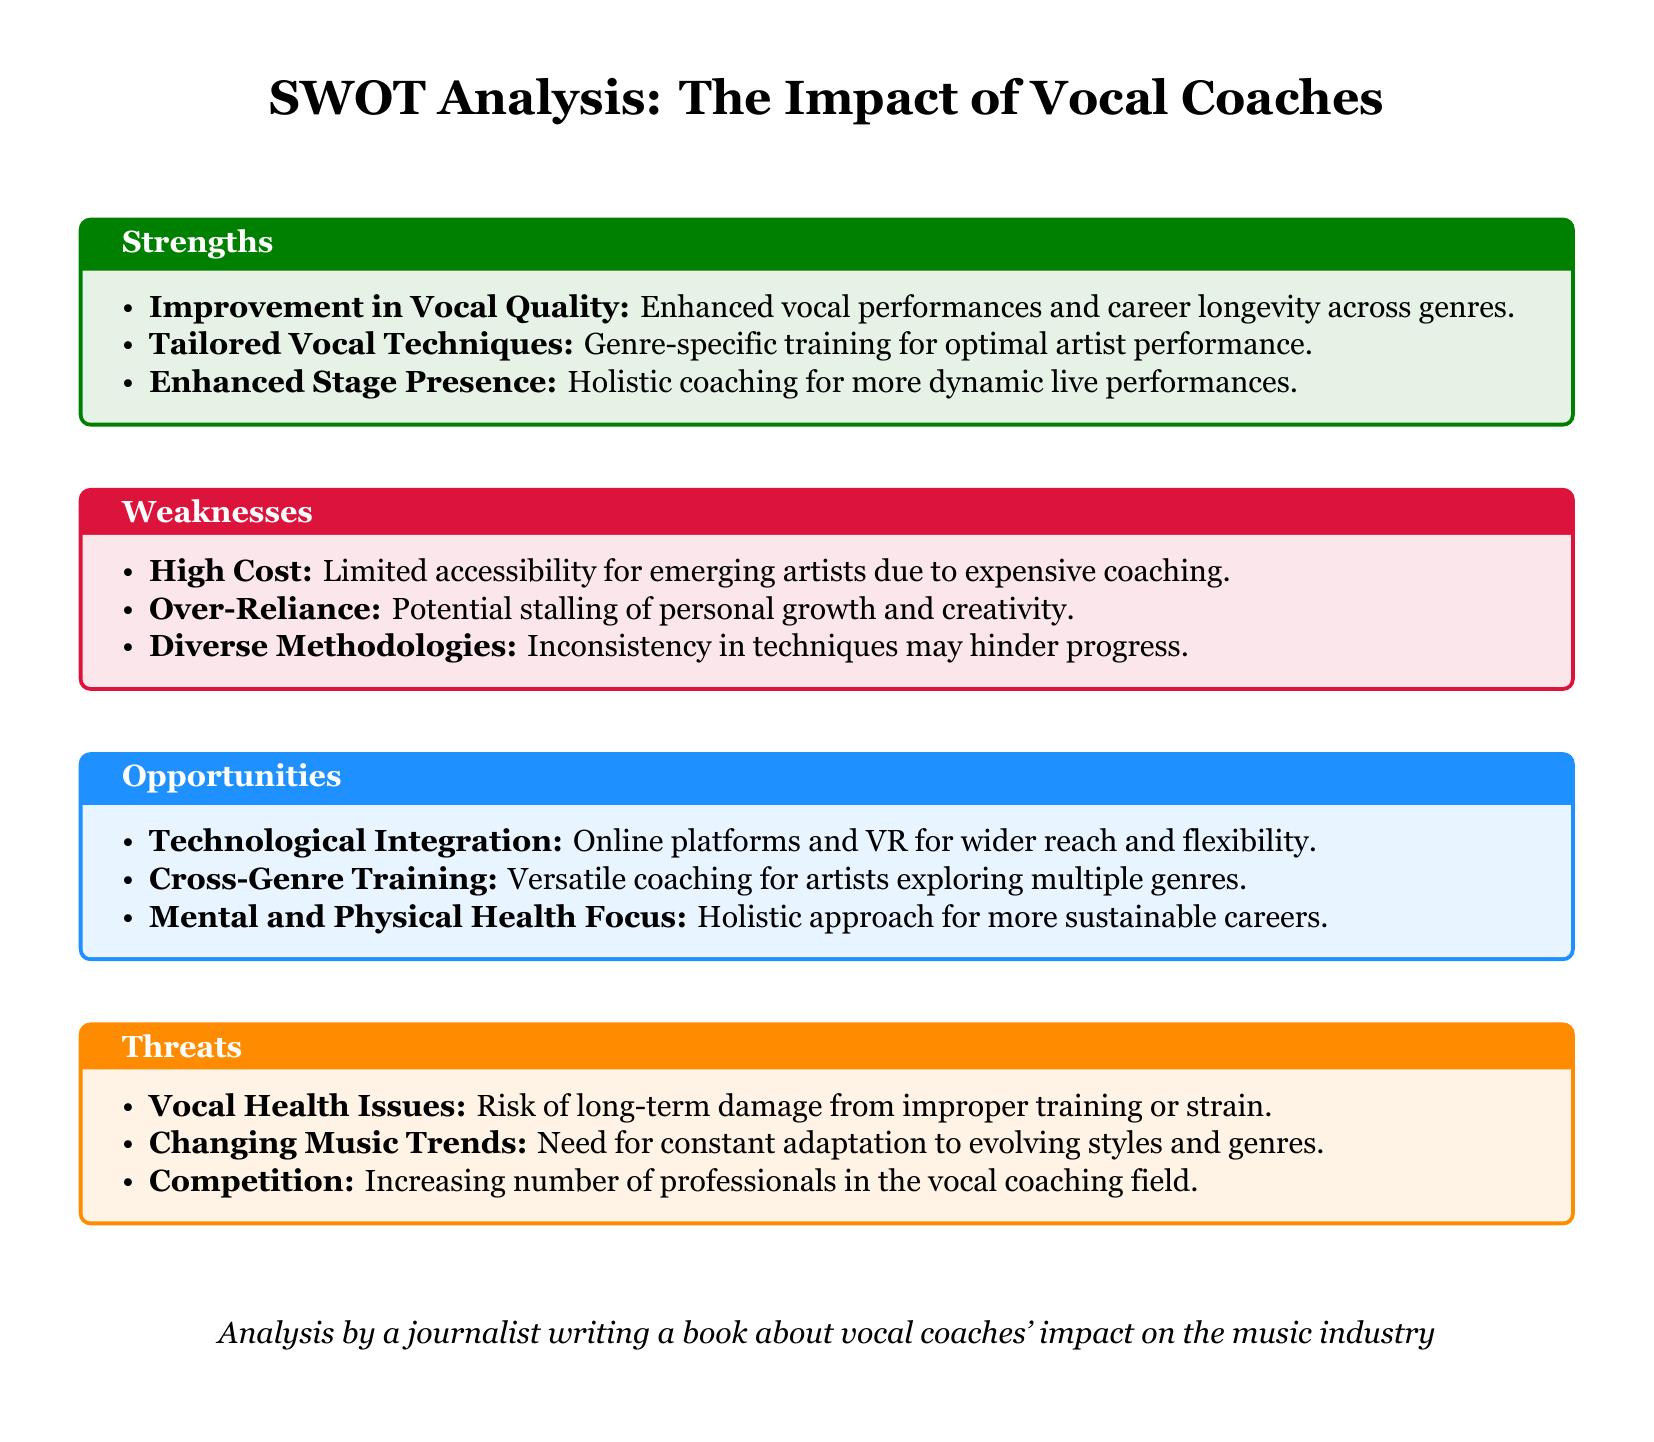What is one key strength of vocal coaches? The document states that one key strength is the improvement in vocal quality, which enhances vocal performances and career longevity across genres.
Answer: Improvement in Vocal Quality What is a noted weakness related to vocal coaching? A noted weakness is the high cost, which limits accessibility for emerging artists due to expensive coaching.
Answer: High Cost What opportunity is highlighted regarding the integration of technology? The document mentions technological integration as an opportunity due to online platforms and VR for wider reach and flexibility.
Answer: Technological Integration What threat does the document identify concerning vocal health? The threat identified is vocal health issues, specifically the risk of long-term damage from improper training or strain.
Answer: Vocal Health Issues How do vocal coaches enhance an artist's performance according to the strengths section? They enhance an artist's performance by providing tailored vocal techniques that are specific to each genre.
Answer: Tailored Vocal Techniques What is one potential risk related to coaching methods mentioned? One potential risk is the over-reliance on vocal coaches, which can stall personal growth and creativity.
Answer: Over-Reliance What aspect does the document mention as crucial for sustainable careers? The document highlights a focus on mental and physical health as crucial for more sustainable careers in music.
Answer: Mental and Physical Health Focus How does the document describe competition in the vocal coaching field? It describes competition as an increasing number of professionals in the vocal coaching field, presenting a threat.
Answer: Competition What is the primary intent of the analysis? The primary intent of the analysis is to evaluate the impact of vocal coaches on the music industry.
Answer: Evaluate Impact 